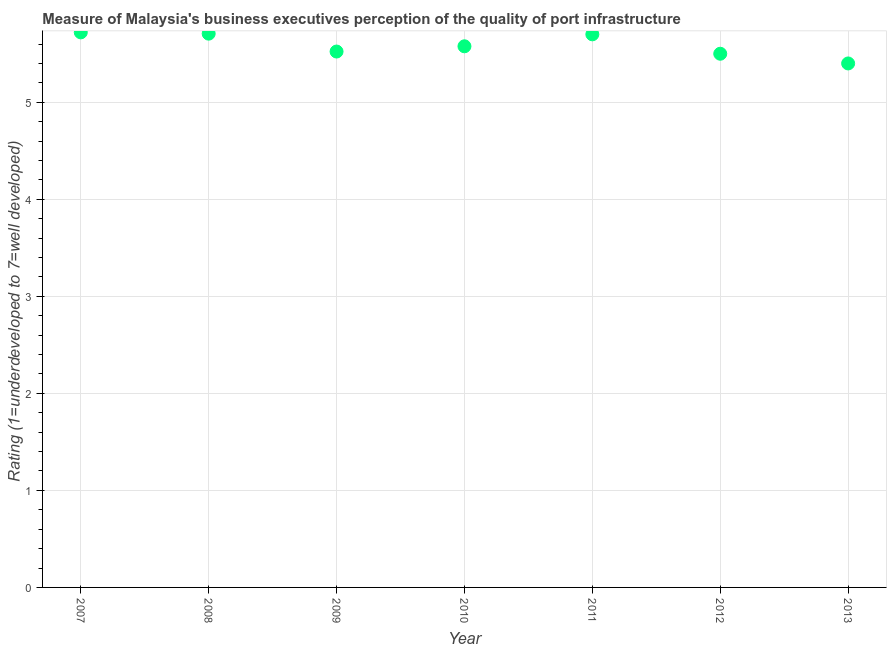What is the rating measuring quality of port infrastructure in 2007?
Your response must be concise. 5.72. Across all years, what is the maximum rating measuring quality of port infrastructure?
Your answer should be very brief. 5.72. Across all years, what is the minimum rating measuring quality of port infrastructure?
Ensure brevity in your answer.  5.4. In which year was the rating measuring quality of port infrastructure maximum?
Ensure brevity in your answer.  2007. What is the sum of the rating measuring quality of port infrastructure?
Make the answer very short. 39.13. What is the difference between the rating measuring quality of port infrastructure in 2010 and 2013?
Your answer should be very brief. 0.18. What is the average rating measuring quality of port infrastructure per year?
Provide a short and direct response. 5.59. What is the median rating measuring quality of port infrastructure?
Your answer should be very brief. 5.58. Do a majority of the years between 2007 and 2010 (inclusive) have rating measuring quality of port infrastructure greater than 0.6000000000000001 ?
Ensure brevity in your answer.  Yes. What is the ratio of the rating measuring quality of port infrastructure in 2009 to that in 2013?
Provide a succinct answer. 1.02. Is the difference between the rating measuring quality of port infrastructure in 2010 and 2012 greater than the difference between any two years?
Ensure brevity in your answer.  No. What is the difference between the highest and the second highest rating measuring quality of port infrastructure?
Your answer should be compact. 0.01. What is the difference between the highest and the lowest rating measuring quality of port infrastructure?
Provide a short and direct response. 0.32. Does the rating measuring quality of port infrastructure monotonically increase over the years?
Ensure brevity in your answer.  No. How many dotlines are there?
Provide a succinct answer. 1. Does the graph contain any zero values?
Provide a short and direct response. No. What is the title of the graph?
Your answer should be compact. Measure of Malaysia's business executives perception of the quality of port infrastructure. What is the label or title of the Y-axis?
Your answer should be compact. Rating (1=underdeveloped to 7=well developed) . What is the Rating (1=underdeveloped to 7=well developed)  in 2007?
Ensure brevity in your answer.  5.72. What is the Rating (1=underdeveloped to 7=well developed)  in 2008?
Offer a terse response. 5.71. What is the Rating (1=underdeveloped to 7=well developed)  in 2009?
Offer a terse response. 5.52. What is the Rating (1=underdeveloped to 7=well developed)  in 2010?
Keep it short and to the point. 5.58. What is the difference between the Rating (1=underdeveloped to 7=well developed)  in 2007 and 2008?
Keep it short and to the point. 0.01. What is the difference between the Rating (1=underdeveloped to 7=well developed)  in 2007 and 2009?
Provide a short and direct response. 0.2. What is the difference between the Rating (1=underdeveloped to 7=well developed)  in 2007 and 2010?
Offer a terse response. 0.14. What is the difference between the Rating (1=underdeveloped to 7=well developed)  in 2007 and 2011?
Provide a succinct answer. 0.02. What is the difference between the Rating (1=underdeveloped to 7=well developed)  in 2007 and 2012?
Your answer should be very brief. 0.22. What is the difference between the Rating (1=underdeveloped to 7=well developed)  in 2007 and 2013?
Give a very brief answer. 0.32. What is the difference between the Rating (1=underdeveloped to 7=well developed)  in 2008 and 2009?
Keep it short and to the point. 0.18. What is the difference between the Rating (1=underdeveloped to 7=well developed)  in 2008 and 2010?
Provide a short and direct response. 0.13. What is the difference between the Rating (1=underdeveloped to 7=well developed)  in 2008 and 2011?
Your answer should be very brief. 0.01. What is the difference between the Rating (1=underdeveloped to 7=well developed)  in 2008 and 2012?
Your answer should be compact. 0.21. What is the difference between the Rating (1=underdeveloped to 7=well developed)  in 2008 and 2013?
Your answer should be compact. 0.31. What is the difference between the Rating (1=underdeveloped to 7=well developed)  in 2009 and 2010?
Give a very brief answer. -0.05. What is the difference between the Rating (1=underdeveloped to 7=well developed)  in 2009 and 2011?
Ensure brevity in your answer.  -0.18. What is the difference between the Rating (1=underdeveloped to 7=well developed)  in 2009 and 2012?
Make the answer very short. 0.02. What is the difference between the Rating (1=underdeveloped to 7=well developed)  in 2009 and 2013?
Keep it short and to the point. 0.12. What is the difference between the Rating (1=underdeveloped to 7=well developed)  in 2010 and 2011?
Provide a succinct answer. -0.12. What is the difference between the Rating (1=underdeveloped to 7=well developed)  in 2010 and 2012?
Your answer should be compact. 0.08. What is the difference between the Rating (1=underdeveloped to 7=well developed)  in 2010 and 2013?
Your response must be concise. 0.18. What is the difference between the Rating (1=underdeveloped to 7=well developed)  in 2011 and 2013?
Ensure brevity in your answer.  0.3. What is the difference between the Rating (1=underdeveloped to 7=well developed)  in 2012 and 2013?
Offer a terse response. 0.1. What is the ratio of the Rating (1=underdeveloped to 7=well developed)  in 2007 to that in 2009?
Ensure brevity in your answer.  1.04. What is the ratio of the Rating (1=underdeveloped to 7=well developed)  in 2007 to that in 2012?
Your answer should be very brief. 1.04. What is the ratio of the Rating (1=underdeveloped to 7=well developed)  in 2007 to that in 2013?
Ensure brevity in your answer.  1.06. What is the ratio of the Rating (1=underdeveloped to 7=well developed)  in 2008 to that in 2009?
Offer a terse response. 1.03. What is the ratio of the Rating (1=underdeveloped to 7=well developed)  in 2008 to that in 2010?
Offer a very short reply. 1.02. What is the ratio of the Rating (1=underdeveloped to 7=well developed)  in 2008 to that in 2012?
Your response must be concise. 1.04. What is the ratio of the Rating (1=underdeveloped to 7=well developed)  in 2008 to that in 2013?
Offer a very short reply. 1.06. What is the ratio of the Rating (1=underdeveloped to 7=well developed)  in 2009 to that in 2010?
Keep it short and to the point. 0.99. What is the ratio of the Rating (1=underdeveloped to 7=well developed)  in 2009 to that in 2011?
Offer a terse response. 0.97. What is the ratio of the Rating (1=underdeveloped to 7=well developed)  in 2010 to that in 2011?
Ensure brevity in your answer.  0.98. What is the ratio of the Rating (1=underdeveloped to 7=well developed)  in 2010 to that in 2012?
Offer a very short reply. 1.01. What is the ratio of the Rating (1=underdeveloped to 7=well developed)  in 2010 to that in 2013?
Your answer should be compact. 1.03. What is the ratio of the Rating (1=underdeveloped to 7=well developed)  in 2011 to that in 2012?
Your answer should be compact. 1.04. What is the ratio of the Rating (1=underdeveloped to 7=well developed)  in 2011 to that in 2013?
Make the answer very short. 1.06. 